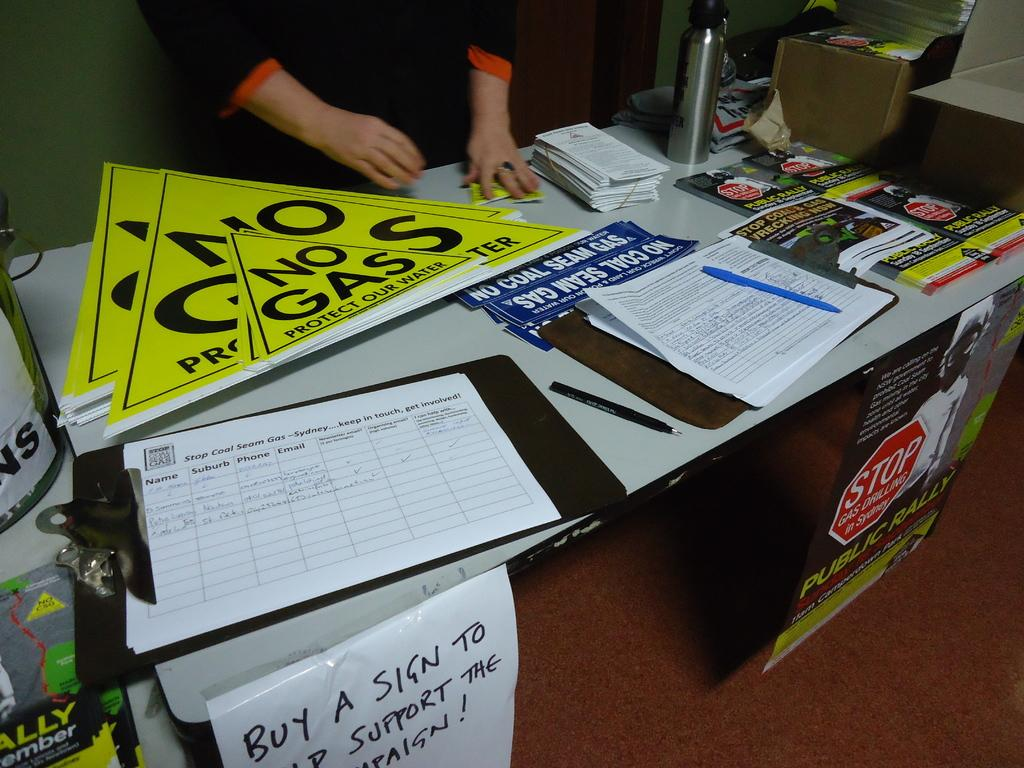<image>
Relay a brief, clear account of the picture shown. A table is set up to sell signs in support of a No Gas protest. 